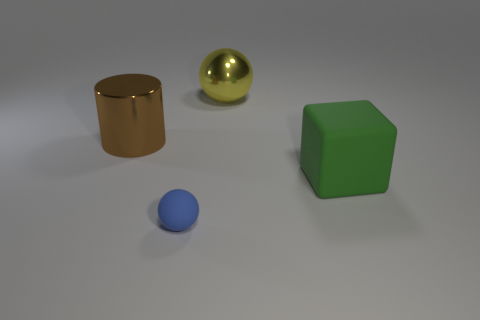Is the big brown thing behind the large matte block made of the same material as the thing to the right of the big metallic sphere? Based on the image, the big brown object behind the matte block appears to be a cylinder that, like the block and sphere, reflects light in a specific manner suggesting a polished surface, possibly metallic. This is in contrast to the material of the smaller object to the right of the metallic sphere, which does not exhibit a reflective quality and seems to be made of a matte or possibly plastic material. Therefore, the two objects are not made of the same material as their surface properties differ. 